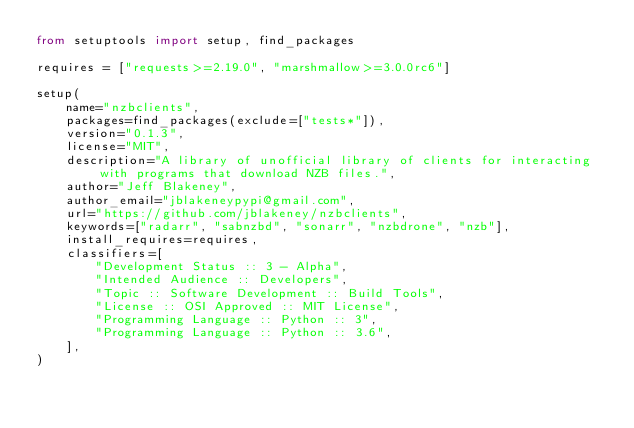<code> <loc_0><loc_0><loc_500><loc_500><_Python_>from setuptools import setup, find_packages

requires = ["requests>=2.19.0", "marshmallow>=3.0.0rc6"]

setup(
    name="nzbclients",
    packages=find_packages(exclude=["tests*"]),
    version="0.1.3",
    license="MIT",
    description="A library of unofficial library of clients for interacting with programs that download NZB files.",
    author="Jeff Blakeney",
    author_email="jblakeneypypi@gmail.com",
    url="https://github.com/jblakeney/nzbclients",
    keywords=["radarr", "sabnzbd", "sonarr", "nzbdrone", "nzb"],
    install_requires=requires,
    classifiers=[
        "Development Status :: 3 - Alpha",
        "Intended Audience :: Developers",
        "Topic :: Software Development :: Build Tools",
        "License :: OSI Approved :: MIT License",
        "Programming Language :: Python :: 3",
        "Programming Language :: Python :: 3.6",
    ],
)
</code> 